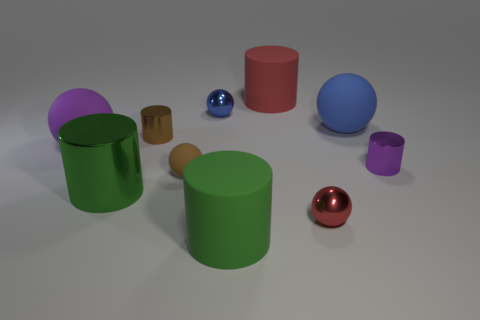Subtract all purple cylinders. How many cylinders are left? 4 Subtract all green metallic cylinders. How many cylinders are left? 4 Subtract 2 balls. How many balls are left? 3 Subtract all yellow spheres. Subtract all cyan cylinders. How many spheres are left? 5 Subtract all red metal balls. Subtract all big blue metallic objects. How many objects are left? 9 Add 8 tiny brown spheres. How many tiny brown spheres are left? 9 Add 2 small cyan metallic balls. How many small cyan metallic balls exist? 2 Subtract 0 blue cylinders. How many objects are left? 10 